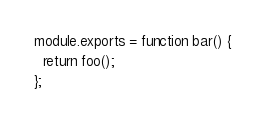Convert code to text. <code><loc_0><loc_0><loc_500><loc_500><_JavaScript_>module.exports = function bar() {
  return foo();
};
</code> 